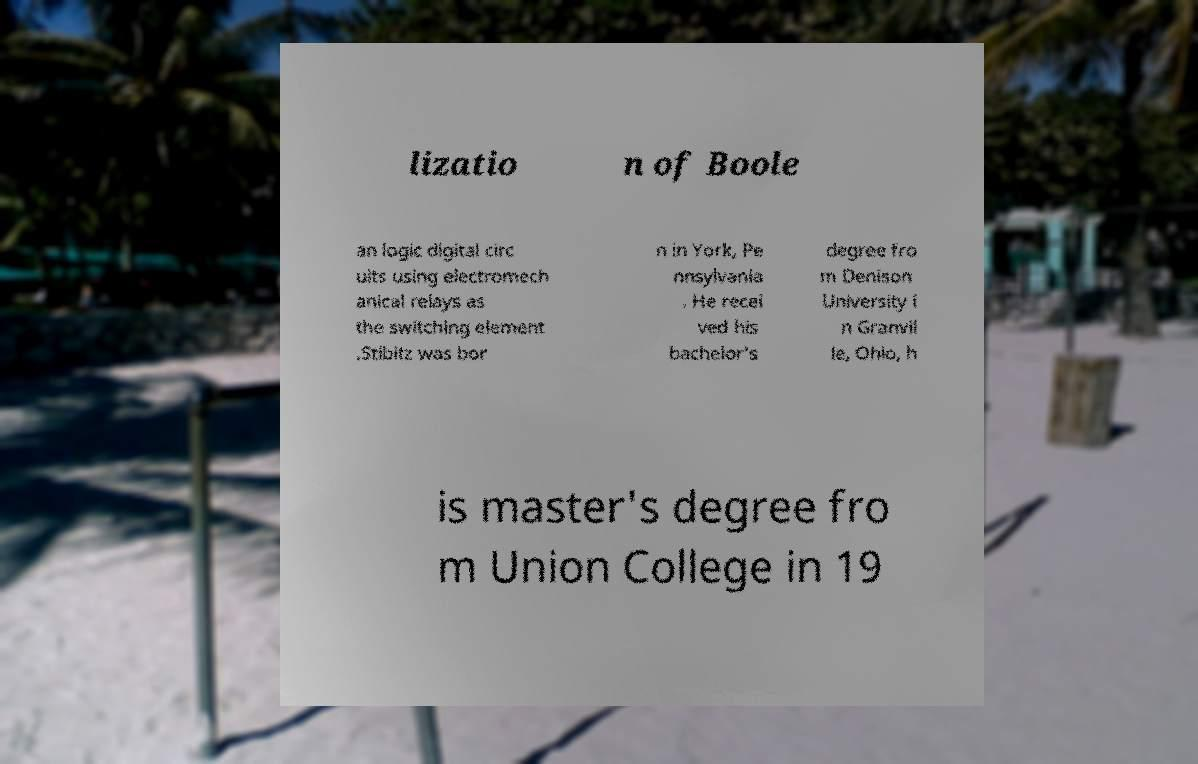Please identify and transcribe the text found in this image. lizatio n of Boole an logic digital circ uits using electromech anical relays as the switching element .Stibitz was bor n in York, Pe nnsylvania . He recei ved his bachelor's degree fro m Denison University i n Granvil le, Ohio, h is master's degree fro m Union College in 19 